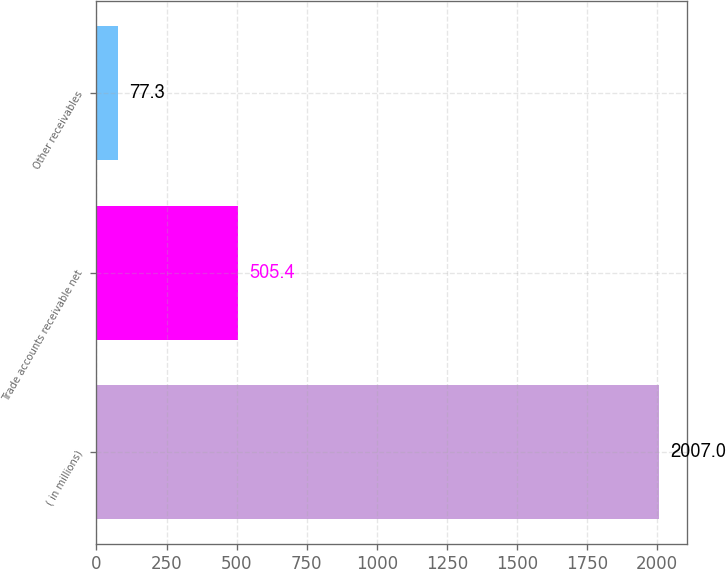<chart> <loc_0><loc_0><loc_500><loc_500><bar_chart><fcel>( in millions)<fcel>Trade accounts receivable net<fcel>Other receivables<nl><fcel>2007<fcel>505.4<fcel>77.3<nl></chart> 